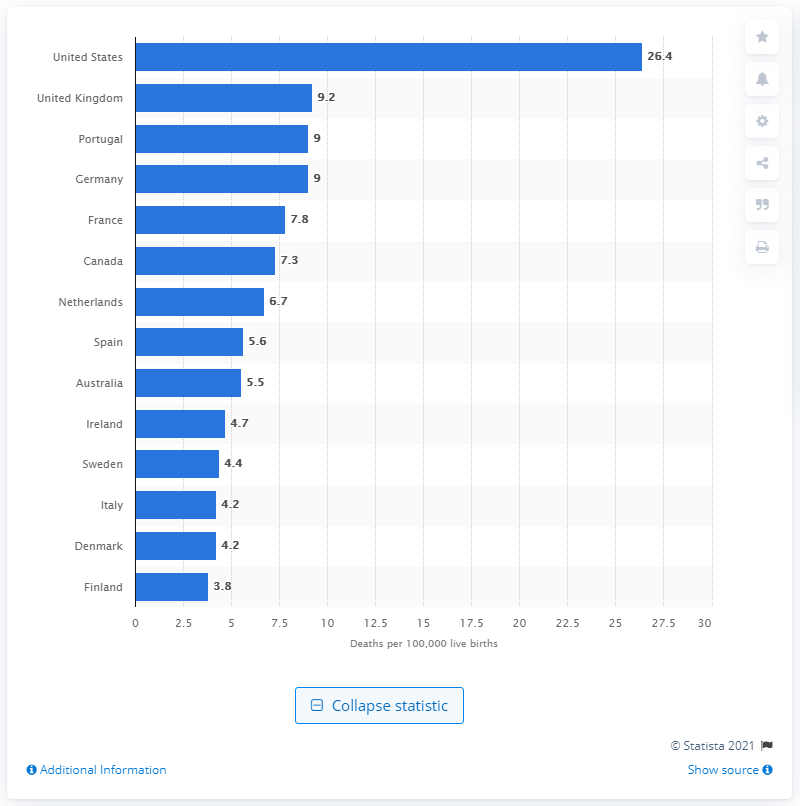Draw attention to some important aspects in this diagram. Finland has the highest maternal mortality rate among developed countries. In 2015, the maternal mortality rate in the United States was 26.4. 